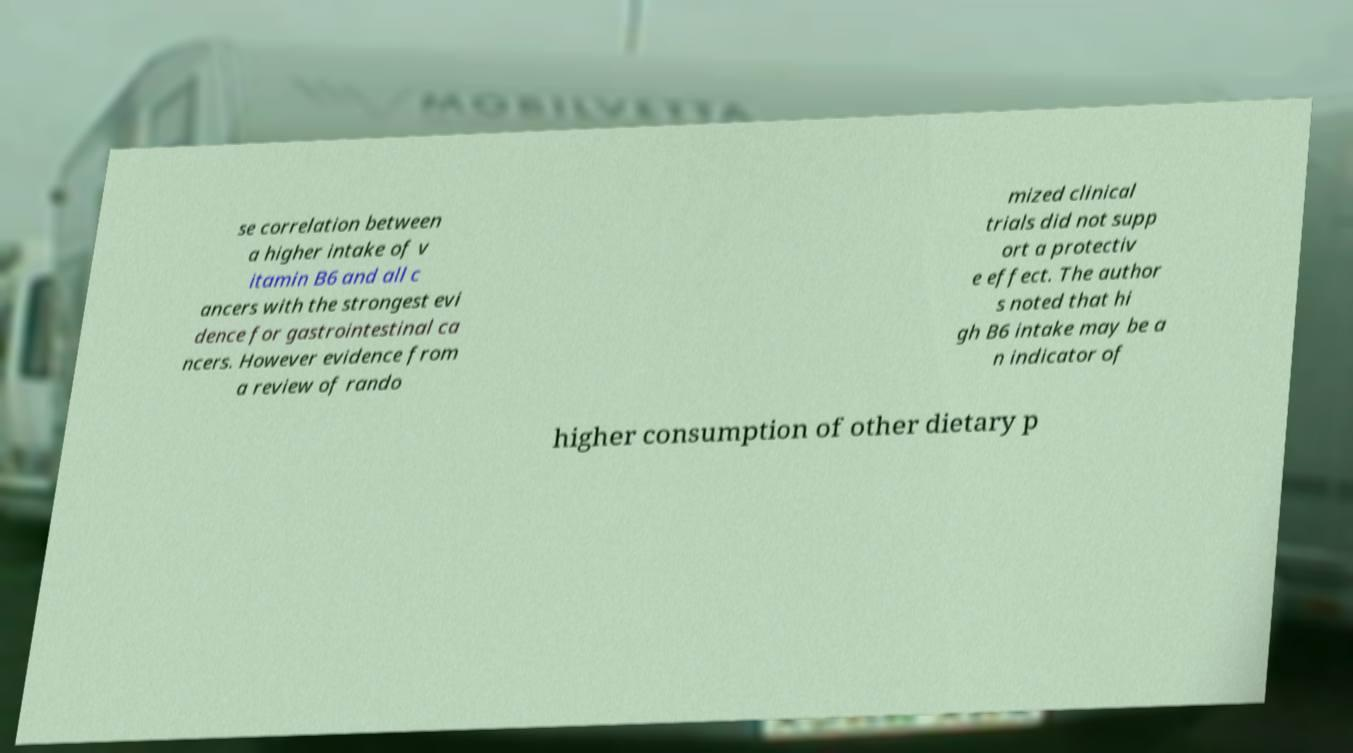I need the written content from this picture converted into text. Can you do that? se correlation between a higher intake of v itamin B6 and all c ancers with the strongest evi dence for gastrointestinal ca ncers. However evidence from a review of rando mized clinical trials did not supp ort a protectiv e effect. The author s noted that hi gh B6 intake may be a n indicator of higher consumption of other dietary p 